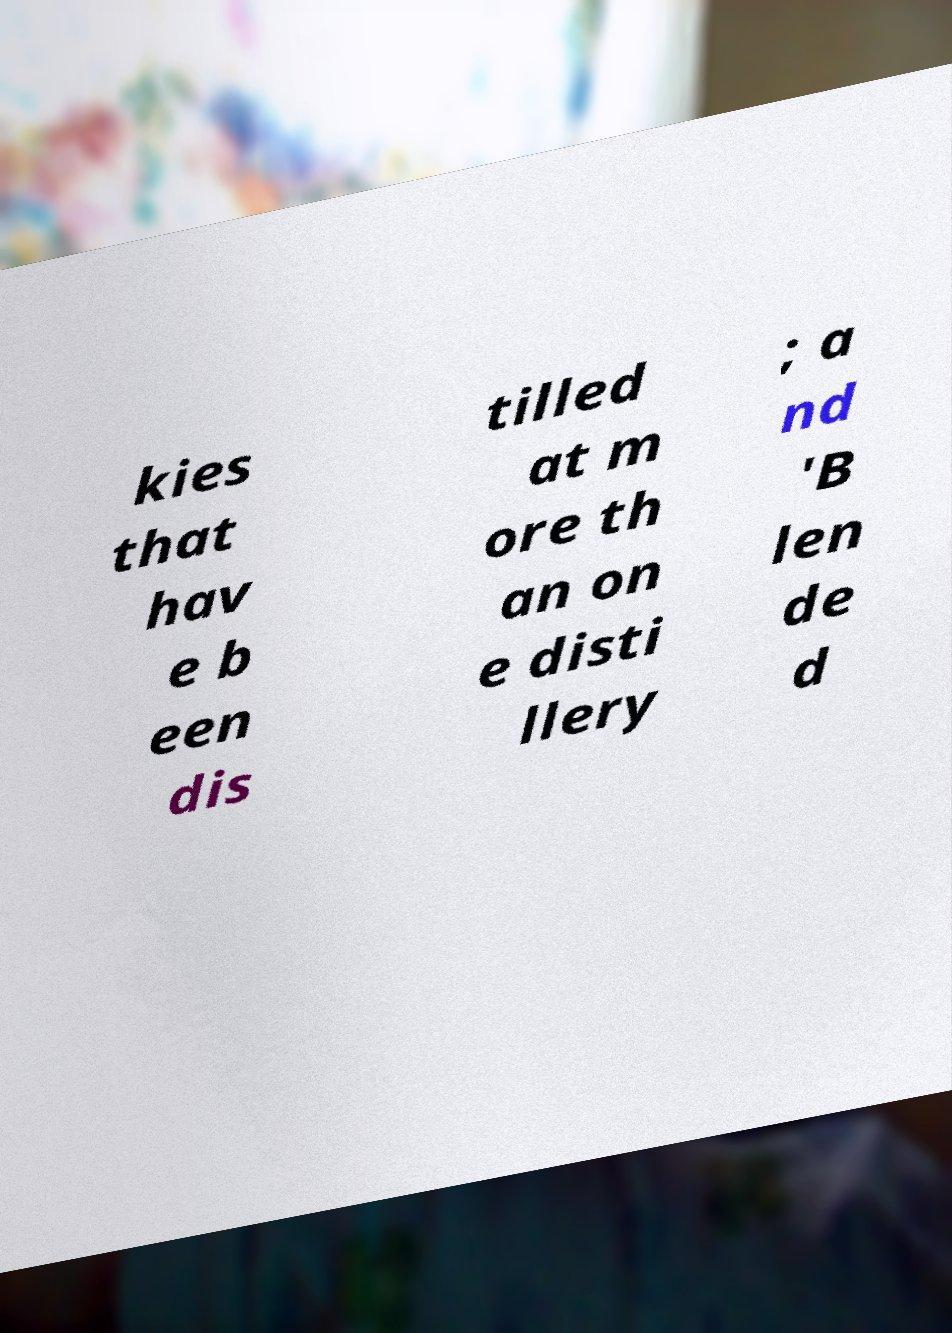For documentation purposes, I need the text within this image transcribed. Could you provide that? kies that hav e b een dis tilled at m ore th an on e disti llery ; a nd 'B len de d 